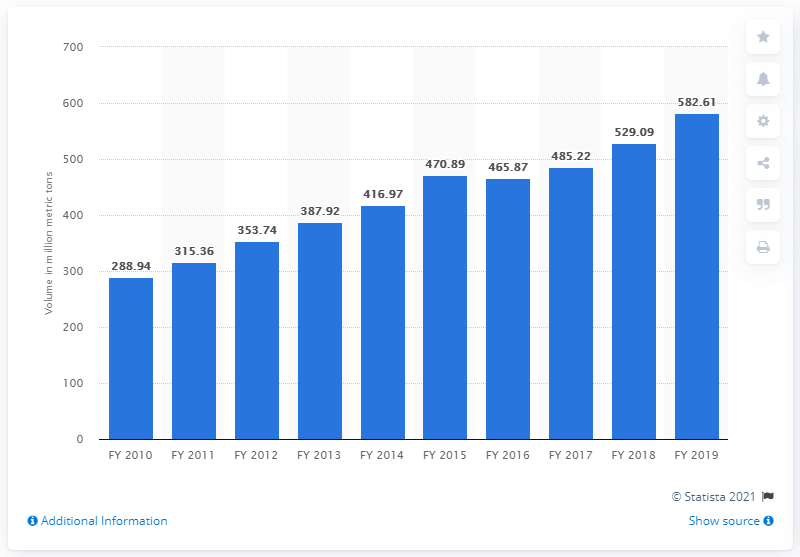Outline some significant characteristics in this image. In 2019, non-major ports in India handled a significant amount of cargo, with the total quantity reaching 582.61 million metric tons. 